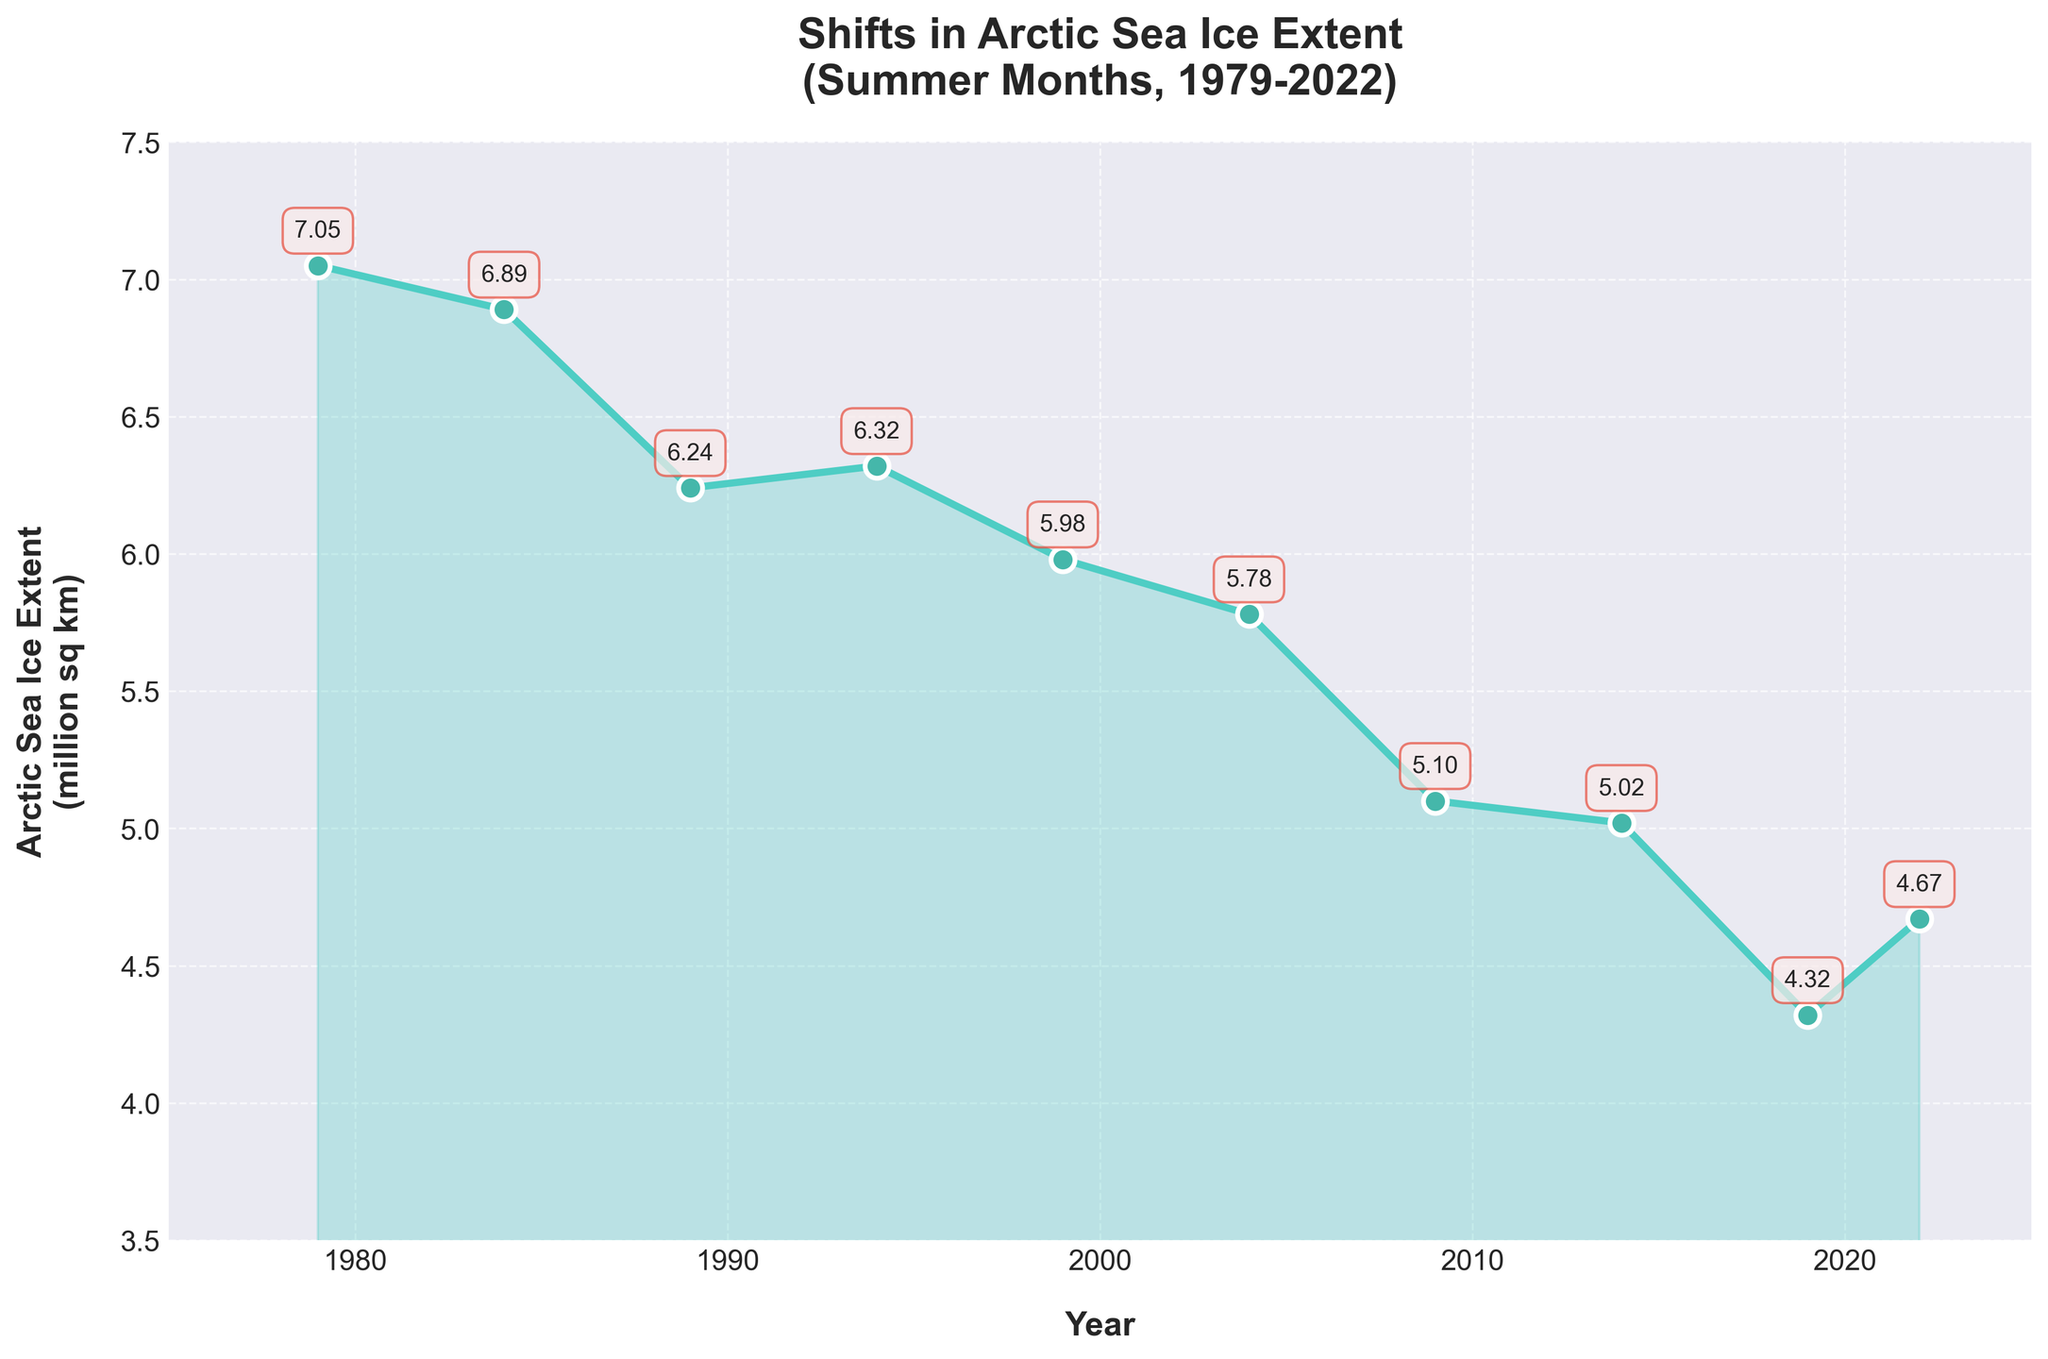What is the general trend of the Arctic sea ice extent from 1979 to 2022? The figure shows a clear downward trend in the Arctic sea ice extent from 1979 (7.05 million sq km) to 2022 (4.67 million sq km). This indicates a consistent reduction in sea ice extent over the years.
Answer: Downward Which year experienced the lowest Arctic sea ice extent? By inspecting the plotted data points, 2019 shows the lowest Arctic sea ice extent at 4.32 million sq km.
Answer: 2019 How much did the Arctic sea ice extent decrease from 1979 to 2019? The Arctic sea ice extent in 1979 was 7.05 million sq km and in 2019 was 4.32 million sq km. The decrease is 7.05 - 4.32 = 2.73 million sq km.
Answer: 2.73 million sq km Compare the Arctic sea ice extent in 1984 and 2004. The extent in 1984 was 6.89 million sq km and in 2004 was 5.78 million sq km. 1984 had a higher sea ice extent compared to 2004.
Answer: 1984 is higher What is the average Arctic sea ice extent for the years listed? To find the average, sum up all the ice extents and divide by the number of years: (7.05 + 6.89 + 6.24 + 6.32 + 5.98 + 5.78 + 5.10 + 5.02 + 4.32 + 4.67) / 10 = 53.37 / 10 = 5.337 million sq km.
Answer: 5.34 million sq km Which two consecutive years had the largest decrease in sea ice extent? Compute the differences between consecutive years: (7.05-6.89)=0.16, (6.89-6.24)=0.65, (6.24-6.32)=-0.08, (6.32-5.98)=0.34, (5.98-5.78)=0.20, (5.78-5.10)=0.68, (5.10-5.02)=0.08, (5.02-4.32)=0.70, and (4.32-4.67)=-0.35. The largest decrease is between 2014 and 2019, with a drop of 0.70 million sq km.
Answer: 2014-2019 What is the visual difference between the ice extents in 1999 and 2022? The Arctic sea ice extent visually declines from 5.98 million sq km in 1999 to 4.67 million sq km in 2022, as shown by the heights of the respective data points. This is a decrease of 1.31 million sq km.
Answer: Decrease of 1.31 million sq km What year had the highest sea ice extent within the dataset? Inspect the figure to find that 1979 had the highest Arctic sea ice extent with a value of 7.05 million sq km.
Answer: 1979 Which decade showed the most significant decline in sea ice extent? The 1980s declined from 7.05 to 6.32 million sq km (-0.73), the 1990s from 6.32 to 5.78 million sq km (-0.54), the 2000s from 5.78 to 5.02 million sq km (-0.76), and the 2010s from 5.02 to 4.32 (-0.70). The 2000s had the most significant decline of 0.76 million sq km.
Answer: 2000s 